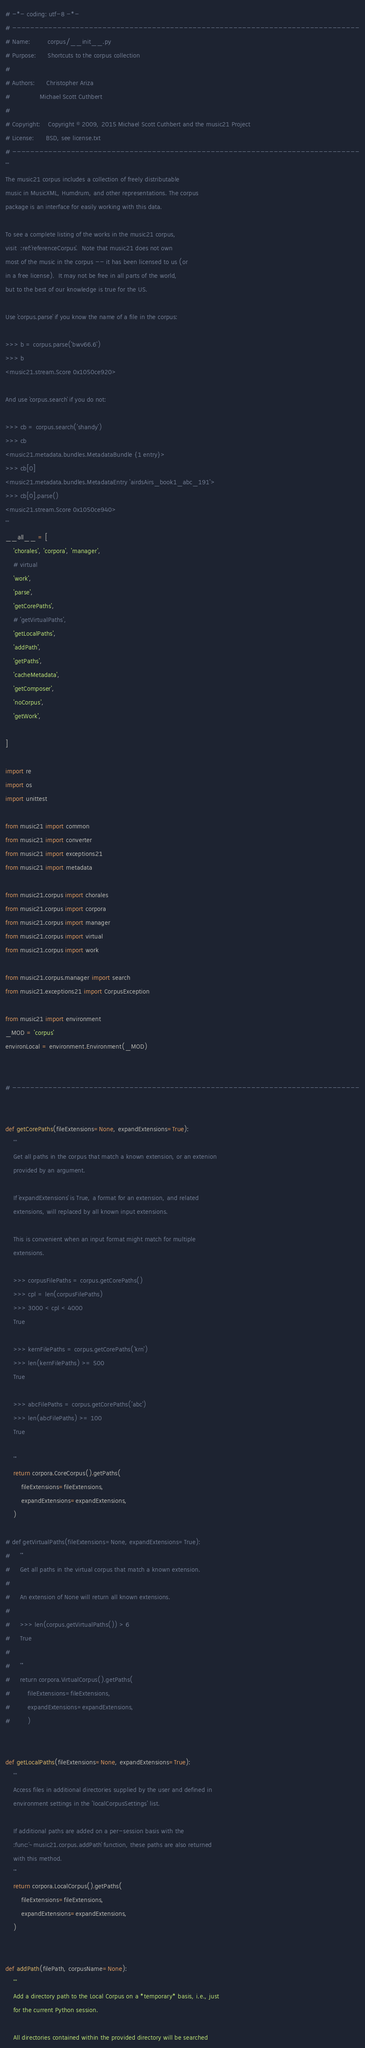Convert code to text. <code><loc_0><loc_0><loc_500><loc_500><_Python_># -*- coding: utf-8 -*-
# -----------------------------------------------------------------------------
# Name:         corpus/__init__.py
# Purpose:      Shortcuts to the corpus collection
#
# Authors:      Christopher Ariza
#               Michael Scott Cuthbert
#
# Copyright:    Copyright © 2009, 2015 Michael Scott Cuthbert and the music21 Project
# License:      BSD, see license.txt
# -----------------------------------------------------------------------------
'''
The music21 corpus includes a collection of freely distributable
music in MusicXML, Humdrum, and other representations. The corpus
package is an interface for easily working with this data.

To see a complete listing of the works in the music21 corpus,
visit  :ref:`referenceCorpus`.  Note that music21 does not own
most of the music in the corpus -- it has been licensed to us (or
in a free license).  It may not be free in all parts of the world,
but to the best of our knowledge is true for the US.

Use `corpus.parse` if you know the name of a file in the corpus:

>>> b = corpus.parse('bwv66.6')
>>> b
<music21.stream.Score 0x1050ce920>

And use `corpus.search` if you do not:

>>> cb = corpus.search('shandy')
>>> cb
<music21.metadata.bundles.MetadataBundle {1 entry}>
>>> cb[0]
<music21.metadata.bundles.MetadataEntry 'airdsAirs_book1_abc_191'>
>>> cb[0].parse()
<music21.stream.Score 0x1050ce940>
'''
__all__ = [
    'chorales', 'corpora', 'manager',
    # virtual
    'work',
    'parse',
    'getCorePaths',
    # 'getVirtualPaths',
    'getLocalPaths',
    'addPath',
    'getPaths',
    'cacheMetadata',
    'getComposer',
    'noCorpus',
    'getWork',

]

import re
import os
import unittest

from music21 import common
from music21 import converter
from music21 import exceptions21
from music21 import metadata

from music21.corpus import chorales
from music21.corpus import corpora
from music21.corpus import manager
from music21.corpus import virtual
from music21.corpus import work

from music21.corpus.manager import search
from music21.exceptions21 import CorpusException

from music21 import environment
_MOD = 'corpus'
environLocal = environment.Environment(_MOD)


# -----------------------------------------------------------------------------


def getCorePaths(fileExtensions=None, expandExtensions=True):
    '''
    Get all paths in the corpus that match a known extension, or an extenion
    provided by an argument.

    If `expandExtensions` is True, a format for an extension, and related
    extensions, will replaced by all known input extensions.

    This is convenient when an input format might match for multiple
    extensions.

    >>> corpusFilePaths = corpus.getCorePaths()
    >>> cpl = len(corpusFilePaths)
    >>> 3000 < cpl < 4000
    True

    >>> kernFilePaths = corpus.getCorePaths('krn')
    >>> len(kernFilePaths) >= 500
    True

    >>> abcFilePaths = corpus.getCorePaths('abc')
    >>> len(abcFilePaths) >= 100
    True

    '''
    return corpora.CoreCorpus().getPaths(
        fileExtensions=fileExtensions,
        expandExtensions=expandExtensions,
    )

# def getVirtualPaths(fileExtensions=None, expandExtensions=True):
#     '''
#     Get all paths in the virtual corpus that match a known extension.
#
#     An extension of None will return all known extensions.
#
#     >>> len(corpus.getVirtualPaths()) > 6
#     True
#
#     '''
#     return corpora.VirtualCorpus().getPaths(
#         fileExtensions=fileExtensions,
#         expandExtensions=expandExtensions,
#         )


def getLocalPaths(fileExtensions=None, expandExtensions=True):
    '''
    Access files in additional directories supplied by the user and defined in
    environment settings in the 'localCorpusSettings' list.

    If additional paths are added on a per-session basis with the
    :func:`~music21.corpus.addPath` function, these paths are also returned
    with this method.
    '''
    return corpora.LocalCorpus().getPaths(
        fileExtensions=fileExtensions,
        expandExtensions=expandExtensions,
    )


def addPath(filePath, corpusName=None):
    '''
    Add a directory path to the Local Corpus on a *temporary* basis, i.e., just
    for the current Python session.

    All directories contained within the provided directory will be searched</code> 